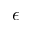Convert formula to latex. <formula><loc_0><loc_0><loc_500><loc_500>\epsilon</formula> 